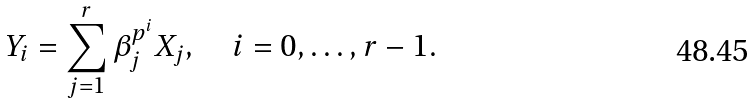<formula> <loc_0><loc_0><loc_500><loc_500>Y _ { i } = \sum _ { j = 1 } ^ { r } \beta _ { j } ^ { p ^ { i } } X _ { j } , \quad i = 0 , \dots , r - 1 .</formula> 